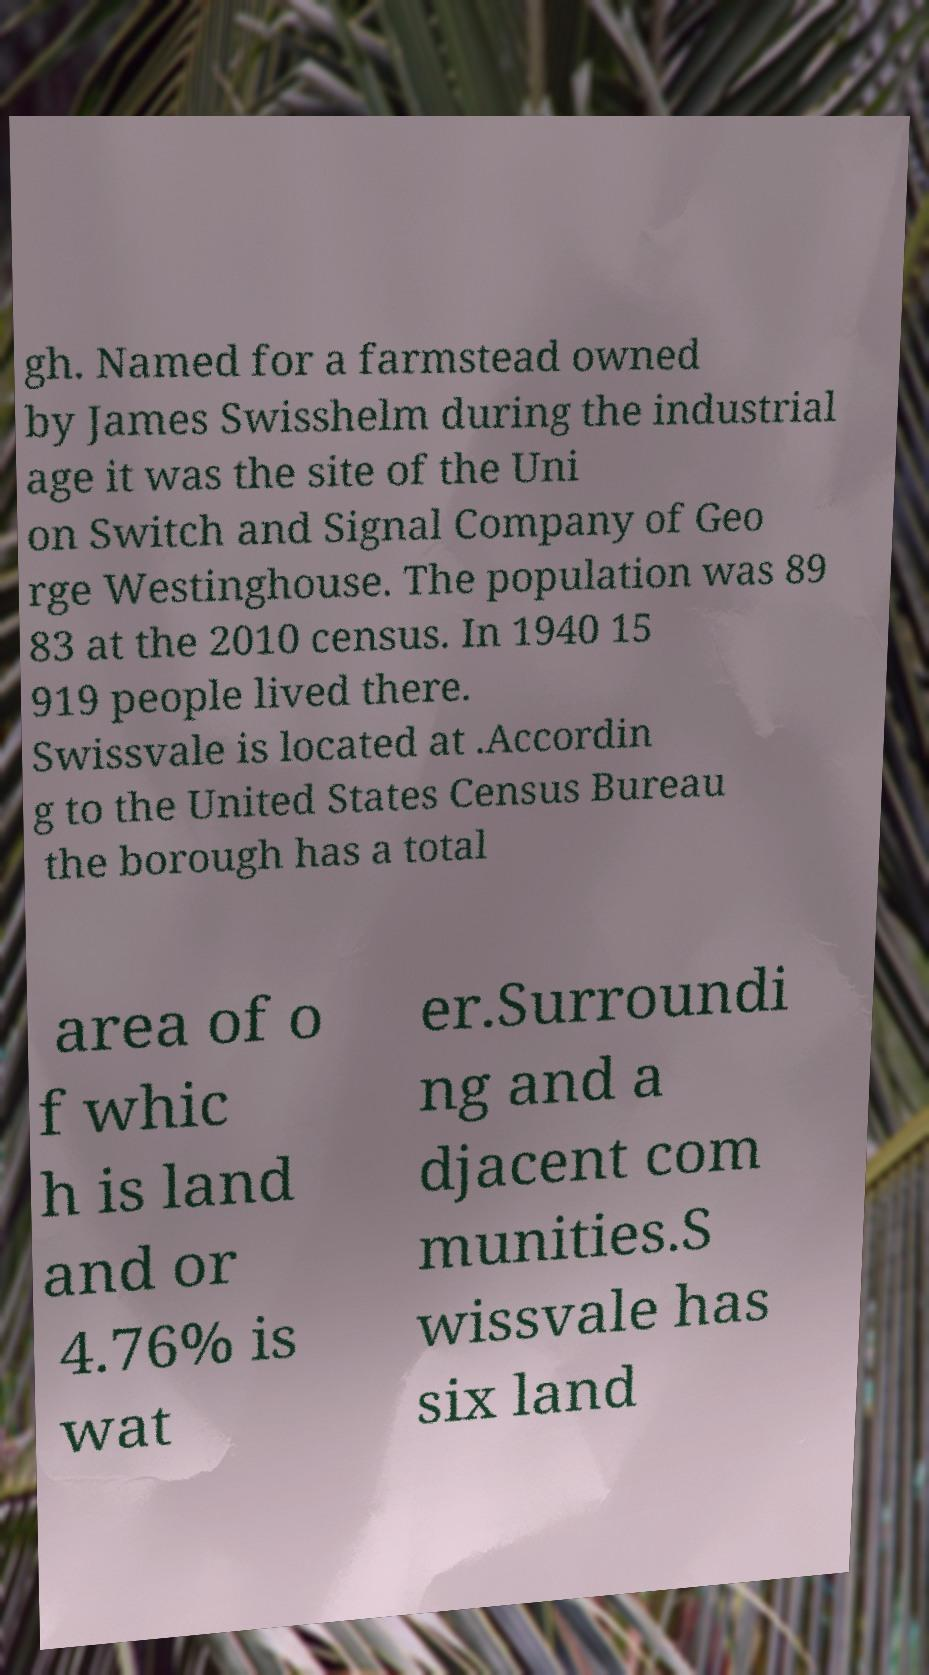What messages or text are displayed in this image? I need them in a readable, typed format. gh. Named for a farmstead owned by James Swisshelm during the industrial age it was the site of the Uni on Switch and Signal Company of Geo rge Westinghouse. The population was 89 83 at the 2010 census. In 1940 15 919 people lived there. Swissvale is located at .Accordin g to the United States Census Bureau the borough has a total area of o f whic h is land and or 4.76% is wat er.Surroundi ng and a djacent com munities.S wissvale has six land 